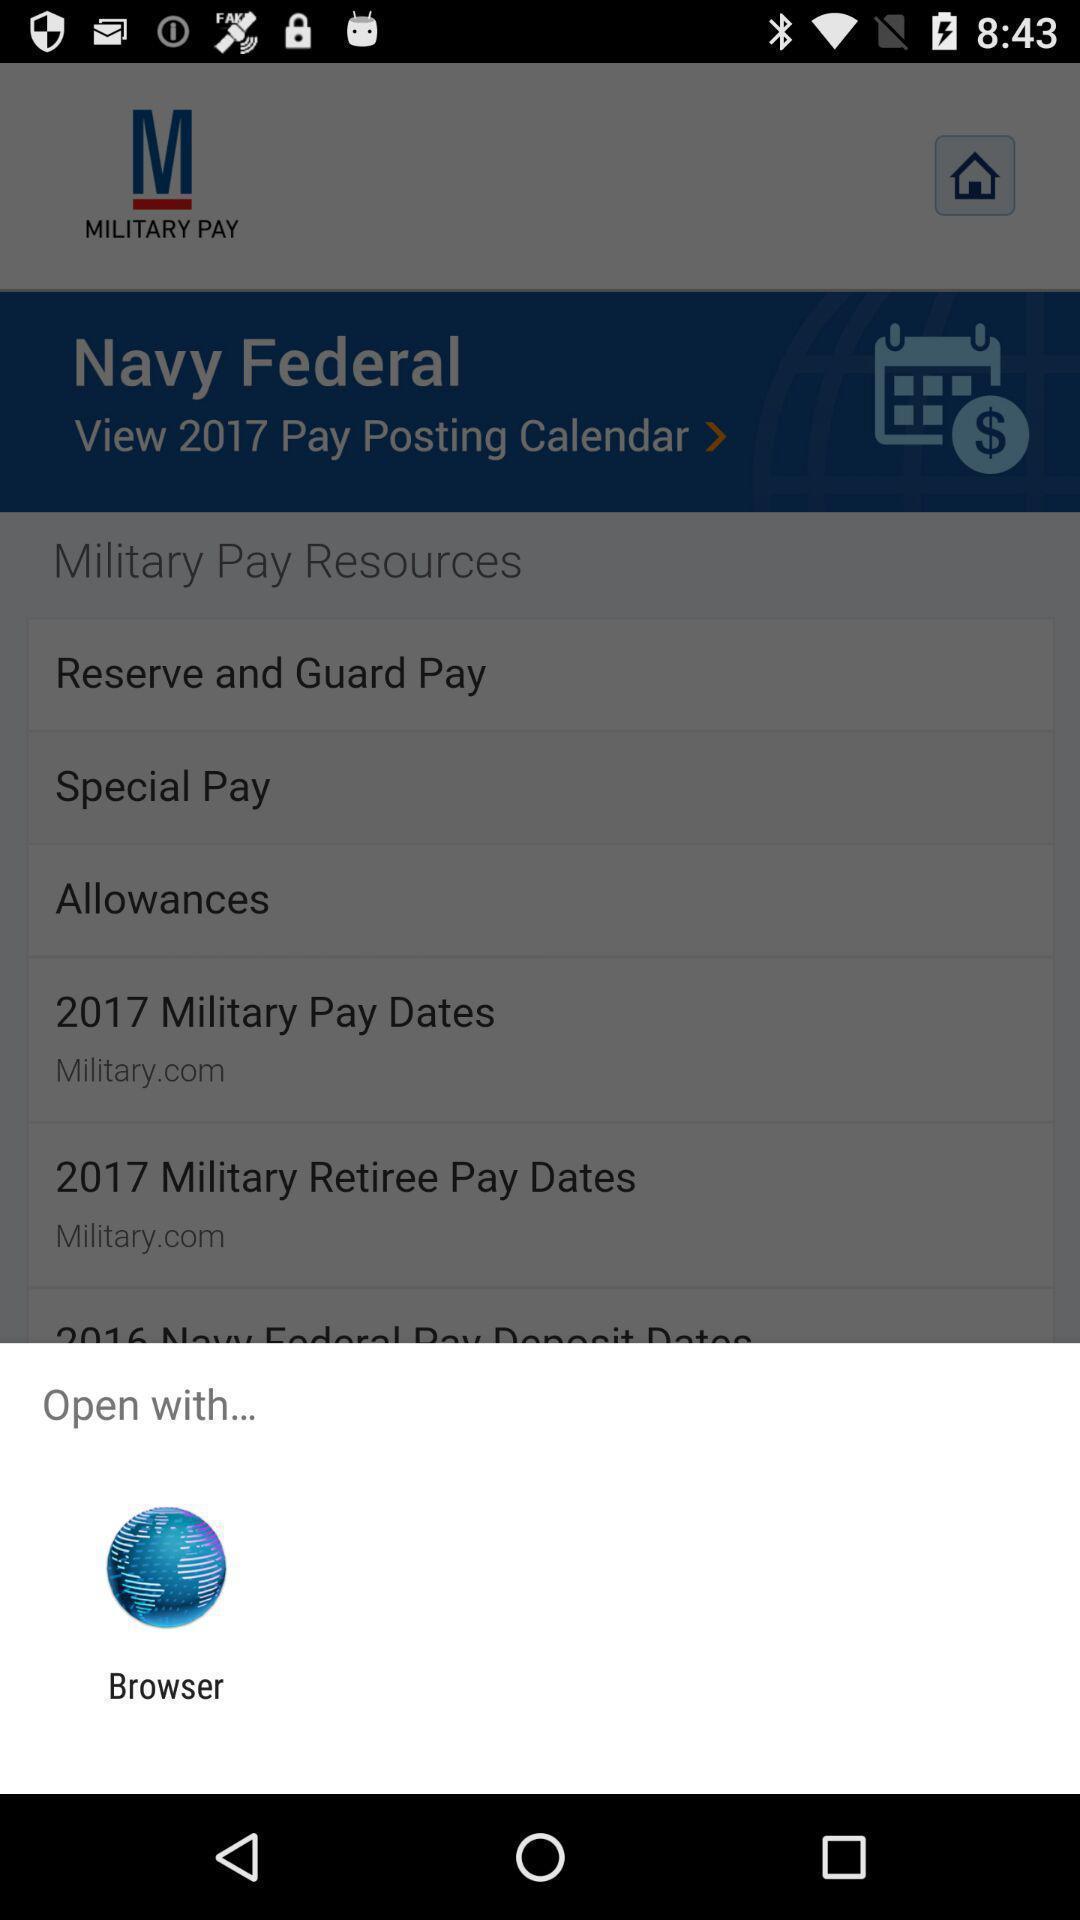Provide a detailed account of this screenshot. Pop-up shows to open with an app. 